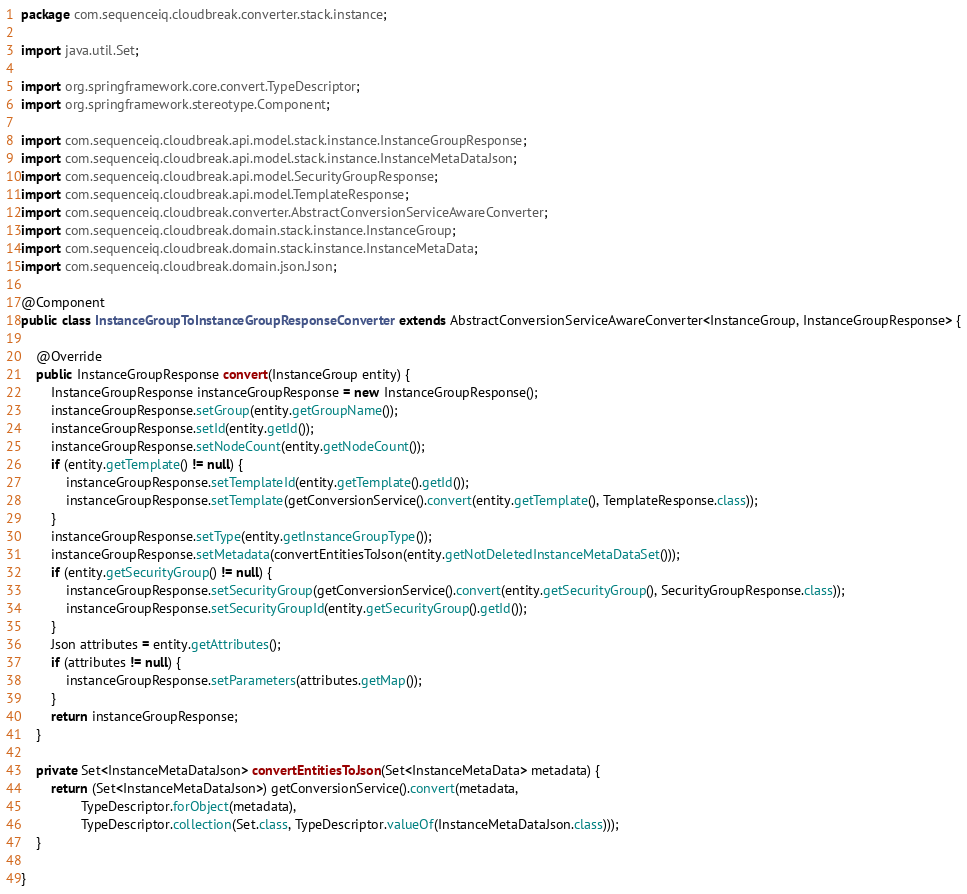Convert code to text. <code><loc_0><loc_0><loc_500><loc_500><_Java_>package com.sequenceiq.cloudbreak.converter.stack.instance;

import java.util.Set;

import org.springframework.core.convert.TypeDescriptor;
import org.springframework.stereotype.Component;

import com.sequenceiq.cloudbreak.api.model.stack.instance.InstanceGroupResponse;
import com.sequenceiq.cloudbreak.api.model.stack.instance.InstanceMetaDataJson;
import com.sequenceiq.cloudbreak.api.model.SecurityGroupResponse;
import com.sequenceiq.cloudbreak.api.model.TemplateResponse;
import com.sequenceiq.cloudbreak.converter.AbstractConversionServiceAwareConverter;
import com.sequenceiq.cloudbreak.domain.stack.instance.InstanceGroup;
import com.sequenceiq.cloudbreak.domain.stack.instance.InstanceMetaData;
import com.sequenceiq.cloudbreak.domain.json.Json;

@Component
public class InstanceGroupToInstanceGroupResponseConverter extends AbstractConversionServiceAwareConverter<InstanceGroup, InstanceGroupResponse> {

    @Override
    public InstanceGroupResponse convert(InstanceGroup entity) {
        InstanceGroupResponse instanceGroupResponse = new InstanceGroupResponse();
        instanceGroupResponse.setGroup(entity.getGroupName());
        instanceGroupResponse.setId(entity.getId());
        instanceGroupResponse.setNodeCount(entity.getNodeCount());
        if (entity.getTemplate() != null) {
            instanceGroupResponse.setTemplateId(entity.getTemplate().getId());
            instanceGroupResponse.setTemplate(getConversionService().convert(entity.getTemplate(), TemplateResponse.class));
        }
        instanceGroupResponse.setType(entity.getInstanceGroupType());
        instanceGroupResponse.setMetadata(convertEntitiesToJson(entity.getNotDeletedInstanceMetaDataSet()));
        if (entity.getSecurityGroup() != null) {
            instanceGroupResponse.setSecurityGroup(getConversionService().convert(entity.getSecurityGroup(), SecurityGroupResponse.class));
            instanceGroupResponse.setSecurityGroupId(entity.getSecurityGroup().getId());
        }
        Json attributes = entity.getAttributes();
        if (attributes != null) {
            instanceGroupResponse.setParameters(attributes.getMap());
        }
        return instanceGroupResponse;
    }

    private Set<InstanceMetaDataJson> convertEntitiesToJson(Set<InstanceMetaData> metadata) {
        return (Set<InstanceMetaDataJson>) getConversionService().convert(metadata,
                TypeDescriptor.forObject(metadata),
                TypeDescriptor.collection(Set.class, TypeDescriptor.valueOf(InstanceMetaDataJson.class)));
    }

}
</code> 